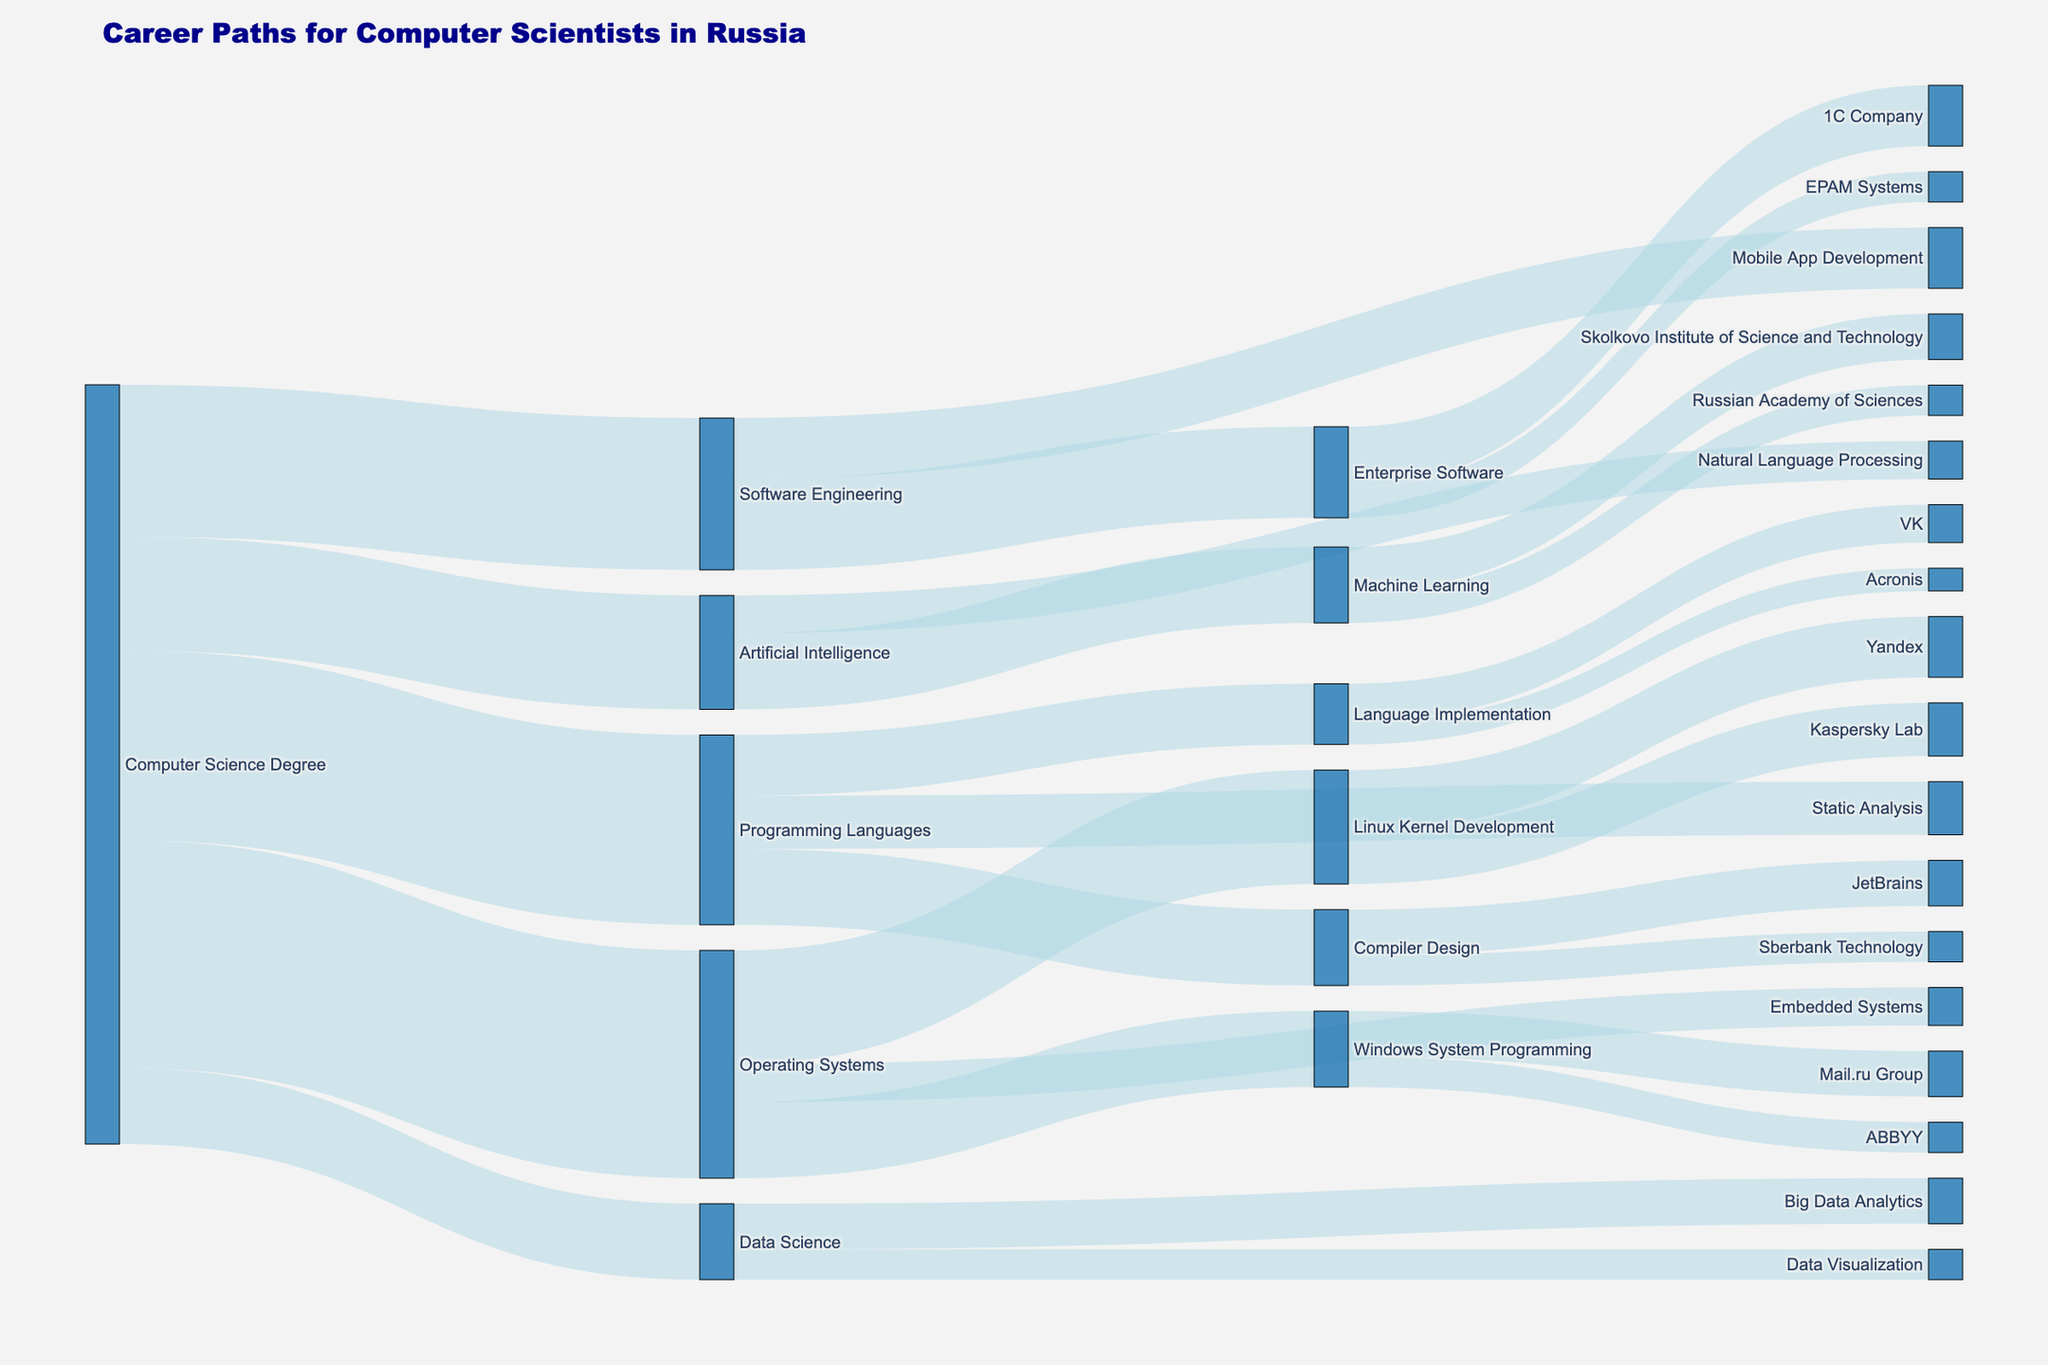1. How many computer scientists pursued a specialization in Programming Languages? Identify the flow from "Computer Science Degree" to "Programming Languages" and note the value associated with it.
Answer: 25 2. Which specialization has the smallest number of computer scientists? Look at the values associated with each direct flow from "Computer Science Degree" to specializations like "Operating Systems," "Programming Languages," etc., and find the smallest number.
Answer: Data Science 3. How many computer scientists worked in Linux Kernel Development? Sum up all the flows ending in "Linux Kernel Development". The values to sum are all those coming from "Operating Systems".
Answer: 15 4. What is the total number of computer scientists who specialized in Operating Systems? Sum up the values going from "Computer Science Degree" to "Operating Systems" specialization.
Answer: 30 5. How does the number of computer scientists specializing in Artificial Intelligence compare to those in Software Engineering? Compare the values of the flows from "Computer Science Degree" to both "Artificial Intelligence" and "Software Engineering."
Answer: Artificial Intelligence has fewer 6. What's the combined value of computer scientists going into Artificial Intelligence or Data Science? Sum the values going from "Computer Science Degree" to both "Artificial Intelligence" and "Data Science."
Answer: 25 7. Which company employs the most computer scientists specialized in Enterprise Software? Look at the values from "Enterprise Software" to "1C Company" and "EPAM Systems" and identify the larger one.
Answer: 1C Company 8. How many computer scientists from Programming Languages went to Language Implementation? Identify the flow from "Programming Languages" to "Language Implementation" and note the value associated with it.
Answer: 8 9. Which has more computer scientists, Big Data Analytics or Windows System Programming at Mail.ru Group? Compare the values of "Data Science" to "Big Data Analytics" and "Windows System Programming" to "Mail.ru Group".
Answer: Windows System Programming at Mail.ru Group 10. What is the combined value of computer scientists working at JetBrains and Sberbank Technology from Compiler Design? Sum the values going from "Compiler Design" to "JetBrains" and "Sberbank Technology."
Answer: 10 